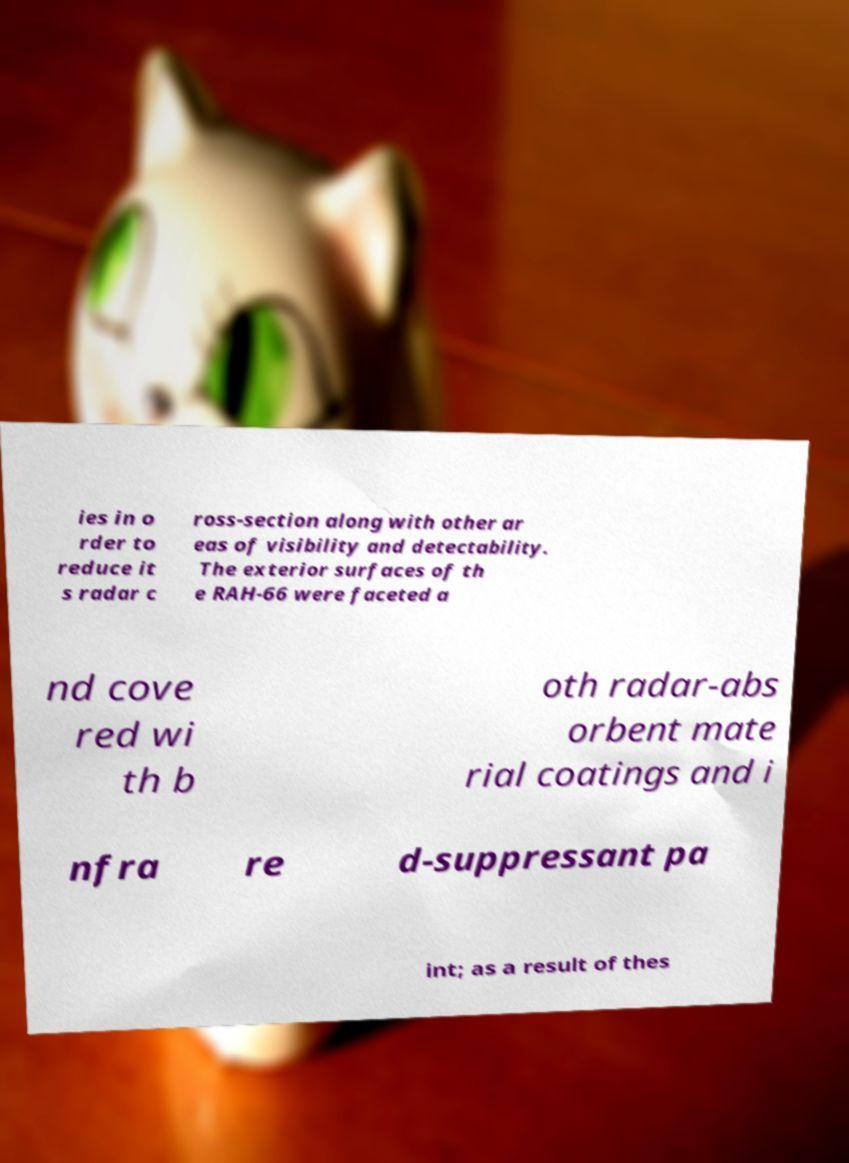Please read and relay the text visible in this image. What does it say? ies in o rder to reduce it s radar c ross-section along with other ar eas of visibility and detectability. The exterior surfaces of th e RAH-66 were faceted a nd cove red wi th b oth radar-abs orbent mate rial coatings and i nfra re d-suppressant pa int; as a result of thes 